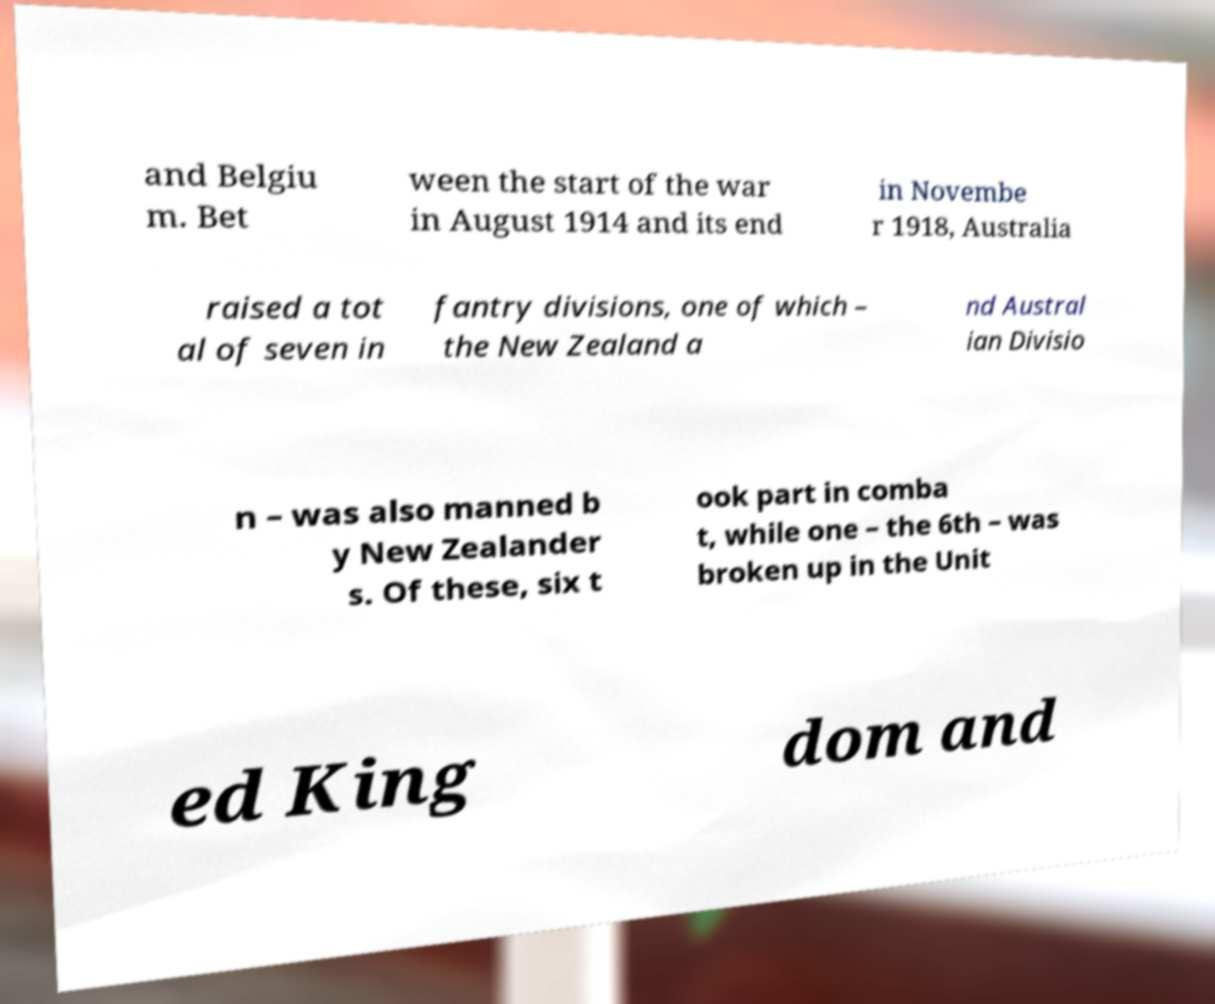There's text embedded in this image that I need extracted. Can you transcribe it verbatim? and Belgiu m. Bet ween the start of the war in August 1914 and its end in Novembe r 1918, Australia raised a tot al of seven in fantry divisions, one of which – the New Zealand a nd Austral ian Divisio n – was also manned b y New Zealander s. Of these, six t ook part in comba t, while one – the 6th – was broken up in the Unit ed King dom and 